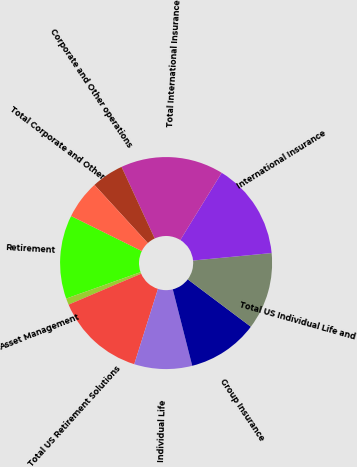Convert chart to OTSL. <chart><loc_0><loc_0><loc_500><loc_500><pie_chart><fcel>Retirement<fcel>Asset Management<fcel>Total US Retirement Solutions<fcel>Individual Life<fcel>Group Insurance<fcel>Total US Individual Life and<fcel>International Insurance<fcel>Total International Insurance<fcel>Corporate and Other operations<fcel>Total Corporate and Other<nl><fcel>12.75%<fcel>0.98%<fcel>13.73%<fcel>8.82%<fcel>10.78%<fcel>11.76%<fcel>14.71%<fcel>15.69%<fcel>4.9%<fcel>5.88%<nl></chart> 